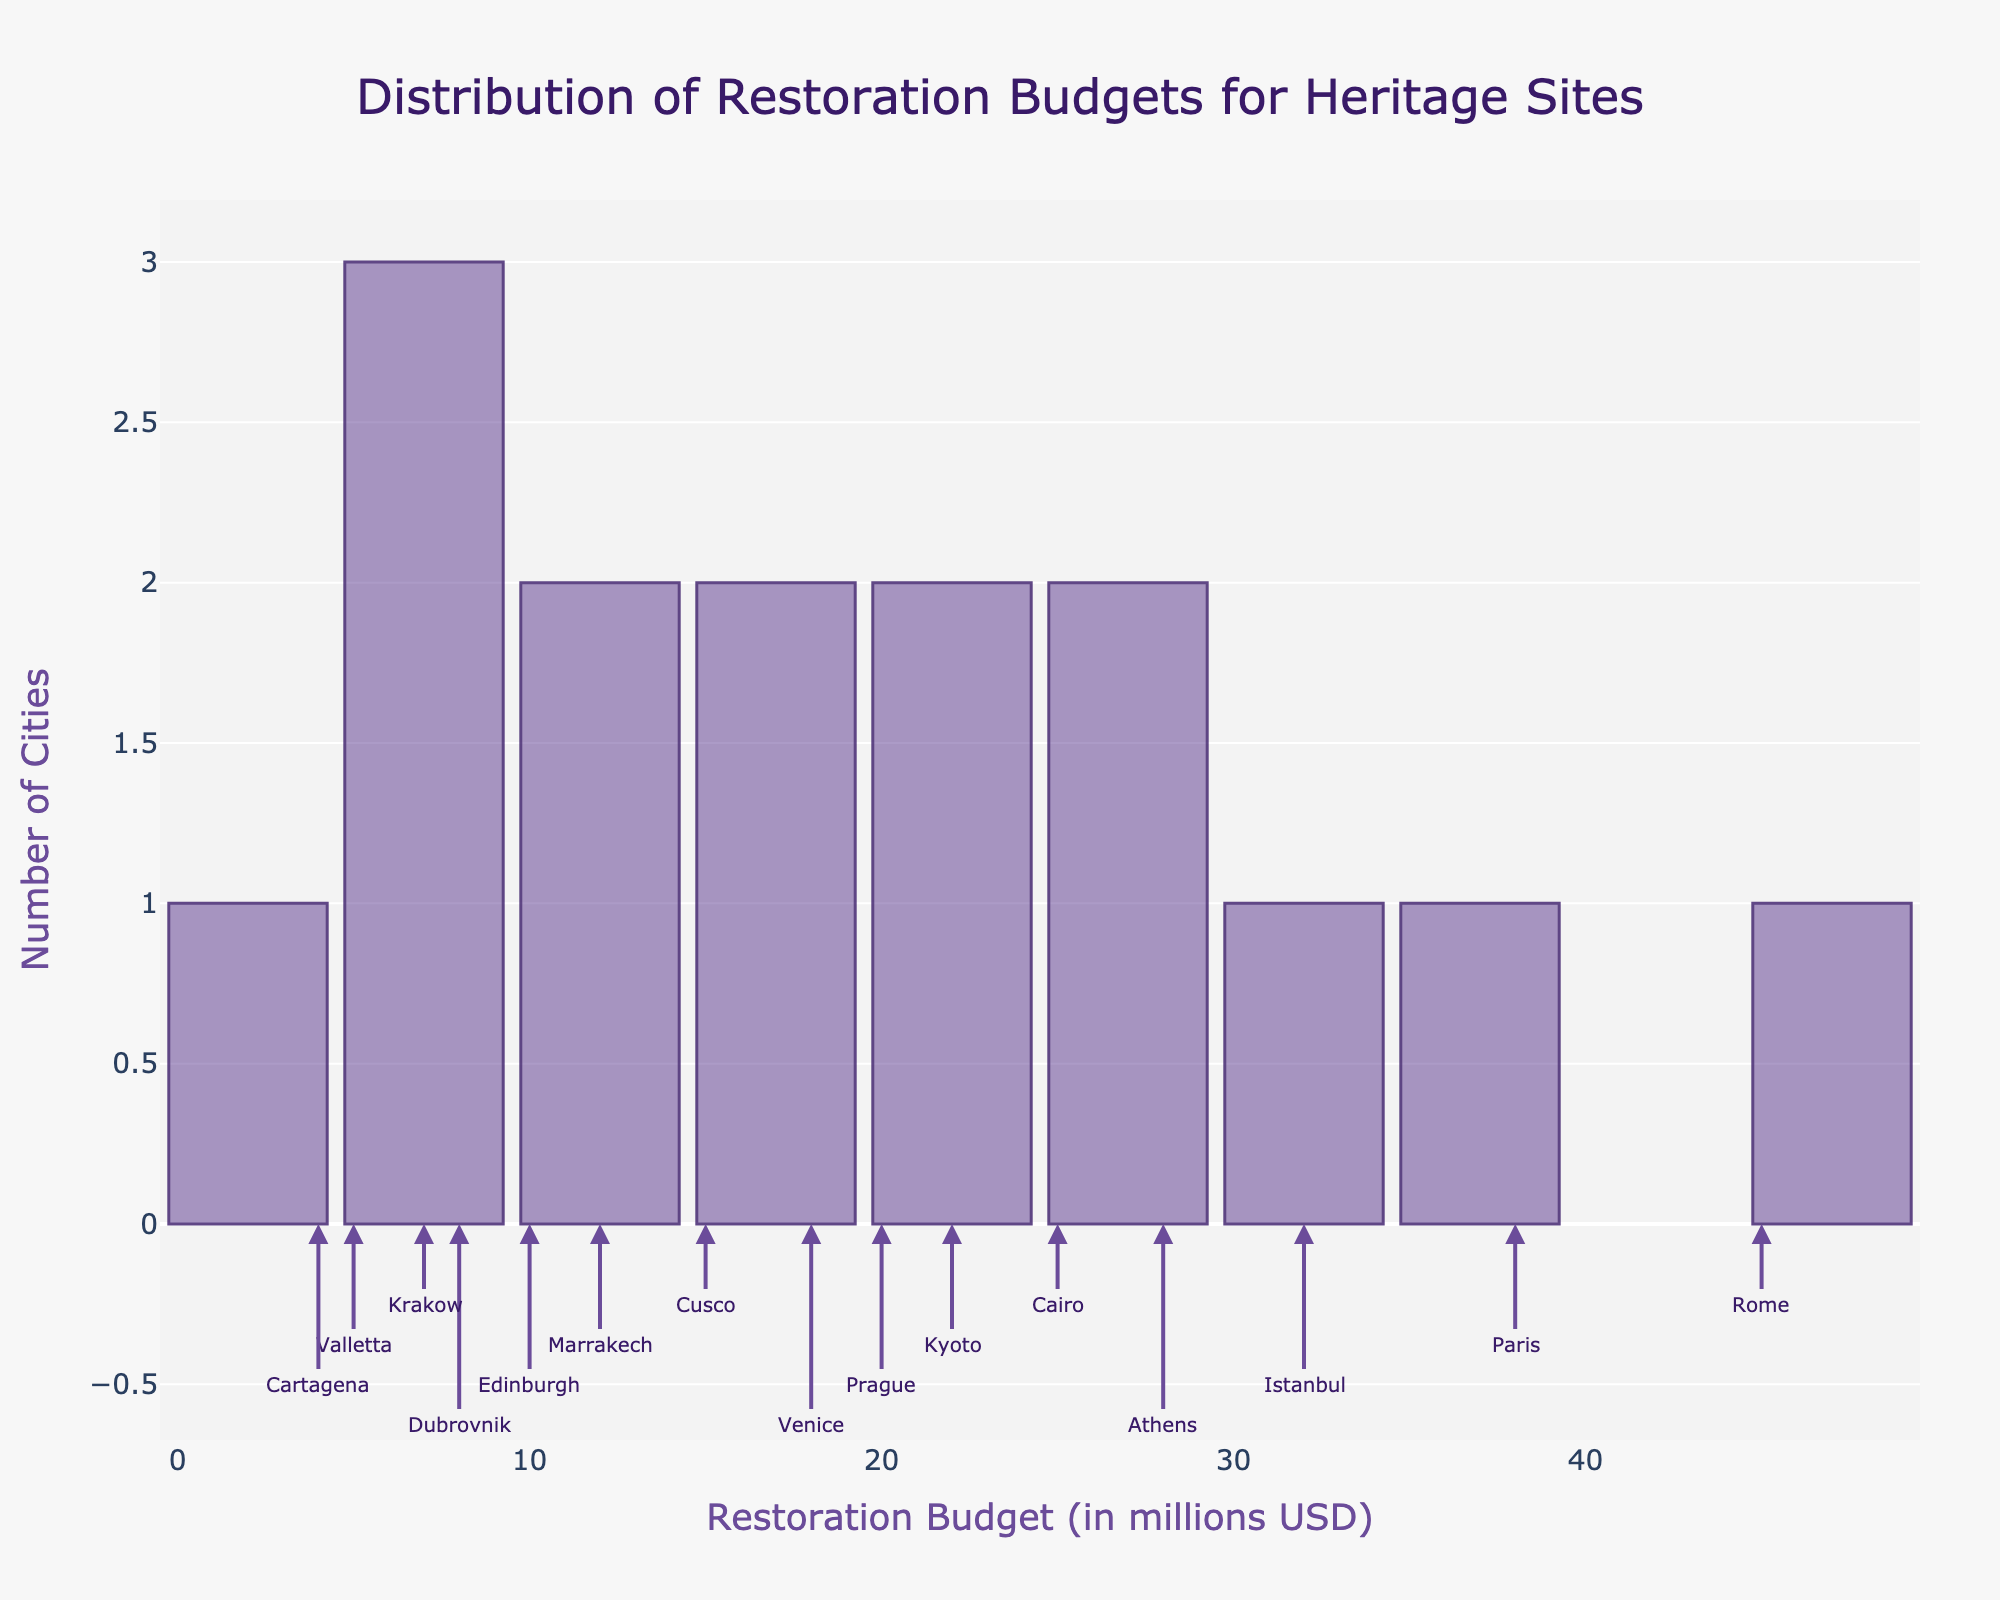How many cities have restoration budgets between 5 and 15 million USD? Look at the bars between 5 and 15 million USD on the x-axis. There are five cities in this range (Valletta, Valletta, Edinburgh, Dubrovnik, Krakow, Cartagena).
Answer: 5 Which city has the highest restoration budget? Check the annotations in the highest bar on the histogram. The annotation "Rome" is closest to the highest bar at 45 million USD on the x-axis.
Answer: Rome What is the range of restoration budgets? The smallest budget is 4 million USD (Cartagena), and the largest is 45 million USD (Rome). Subtract the smallest value from the largest value: 45 - 4.
Answer: 41 million USD How does the restoration budget of Kyoto compare to that of Paris? Find the annotations for "Kyoto" and "Paris" on the histogram. Kyoto is at 22 million USD, and Paris is at 38 million USD. Kyoto's budget is lower than Paris's budget.
Answer: Kyoto's budget is lower What is the median restoration budget? Order the budgets from smallest to largest: 4, 5, 7, 8, 10, 12, 15, 18, 20, 22, 25, 28, 32, 38, 45. The middle budget (median) is the 8th value in this ordered list: 18 million USD.
Answer: 18 million USD Are there more cities with restoration budgets above 20 million USD or below 20 million USD? Count the cities with budgets above 20 million USD: Rome, Paris, Istanbul, Athens, Cairo, Kyoto (6 cities). Count the cities with budgets below 20 million USD: Prague, Venice, Cusco, Marrakech, Edinburgh, Dubrovnik, Krakow, Valletta, Cartagena (9 cities). More cities have budgets below 20 million USD.
Answer: Below 20 million USD How many cities have restoration budgets equal to or above 30 million USD? Look at the bars at or above 30 million USD on the x-axis. There are three cities in this range: Rome, Paris, and Istanbul.
Answer: 3 What is the typical restoration budget for a heritage site in these cities? The most common range is the mode of the histogram. Identify the tallest bar, which is between 5-15 million USD, indicating the typical budgets fall within this range.
Answer: 5-15 million USD 